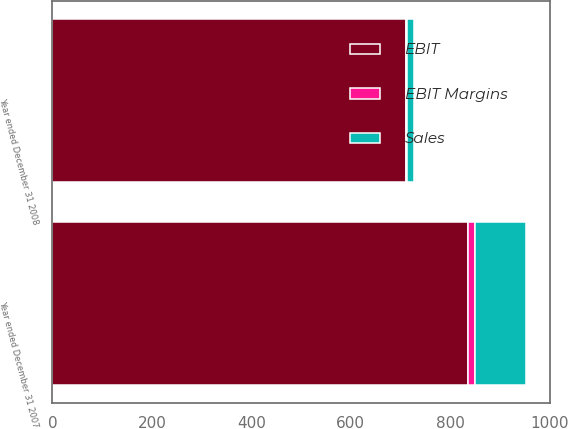Convert chart. <chart><loc_0><loc_0><loc_500><loc_500><stacked_bar_chart><ecel><fcel>Year ended December 31 2008<fcel>Year ended December 31 2007<nl><fcel>EBIT<fcel>711<fcel>837<nl><fcel>Sales<fcel>14<fcel>104<nl><fcel>EBIT Margins<fcel>2<fcel>12.4<nl></chart> 